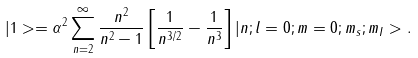Convert formula to latex. <formula><loc_0><loc_0><loc_500><loc_500>| 1 > = \alpha ^ { 2 } \sum _ { n = 2 } ^ { \infty } \frac { n ^ { 2 } } { n ^ { 2 } - 1 } \left [ \frac { 1 } { n ^ { 3 / 2 } } - \frac { 1 } { n ^ { 3 } } \right ] | n ; l = 0 ; m = 0 ; m _ { s } ; m _ { I } > .</formula> 